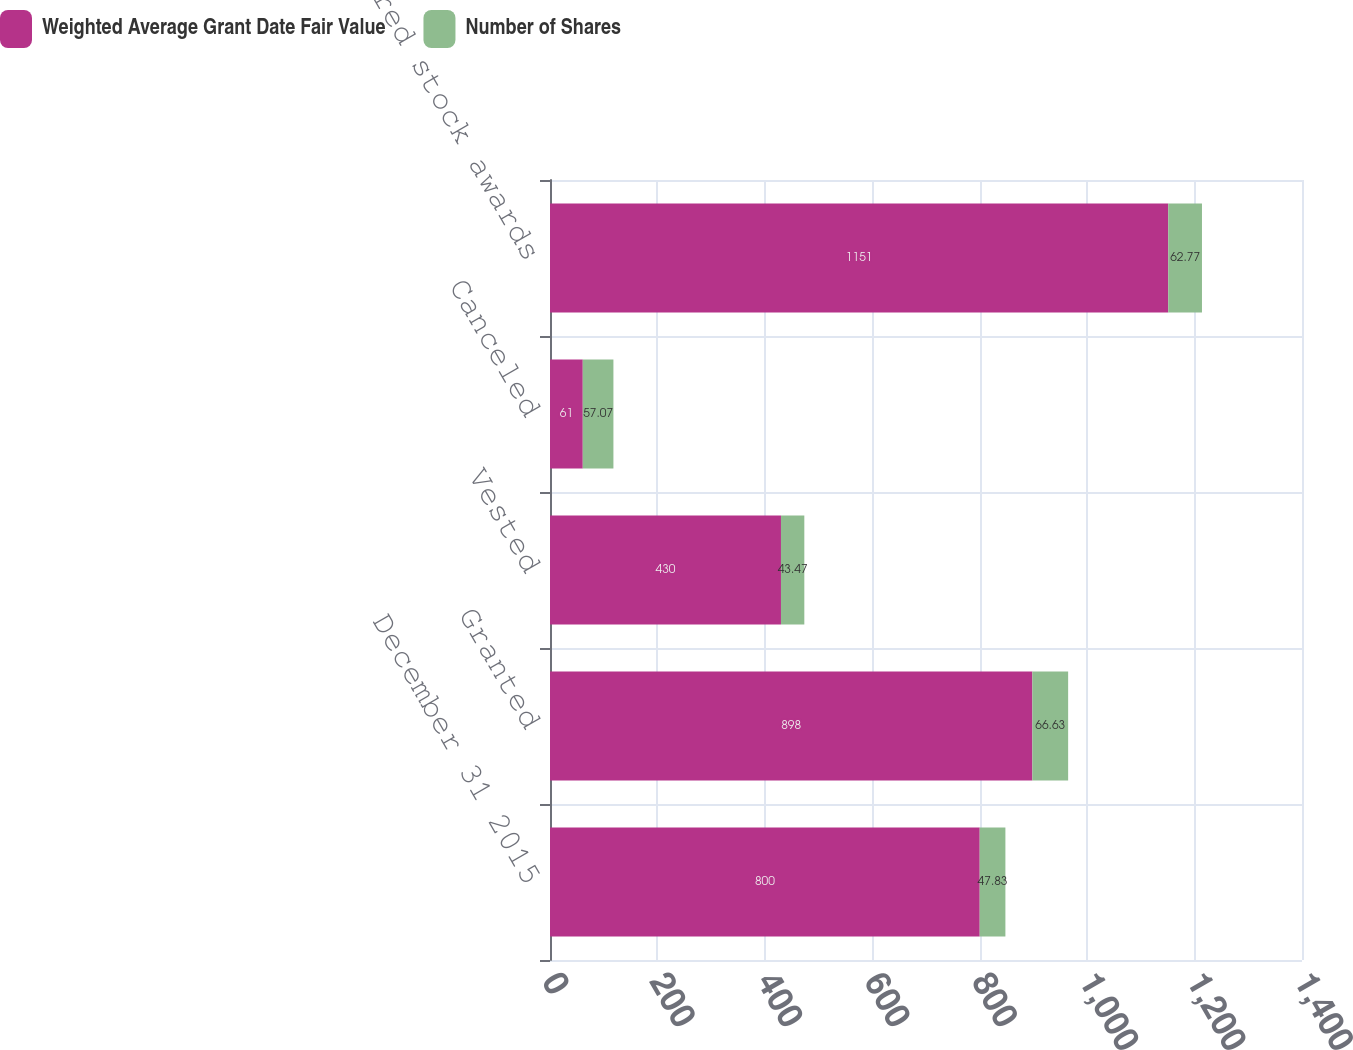Convert chart to OTSL. <chart><loc_0><loc_0><loc_500><loc_500><stacked_bar_chart><ecel><fcel>December 31 2015<fcel>Granted<fcel>Vested<fcel>Canceled<fcel>Unvested deferred stock awards<nl><fcel>Weighted Average Grant Date Fair Value<fcel>800<fcel>898<fcel>430<fcel>61<fcel>1151<nl><fcel>Number of Shares<fcel>47.83<fcel>66.63<fcel>43.47<fcel>57.07<fcel>62.77<nl></chart> 